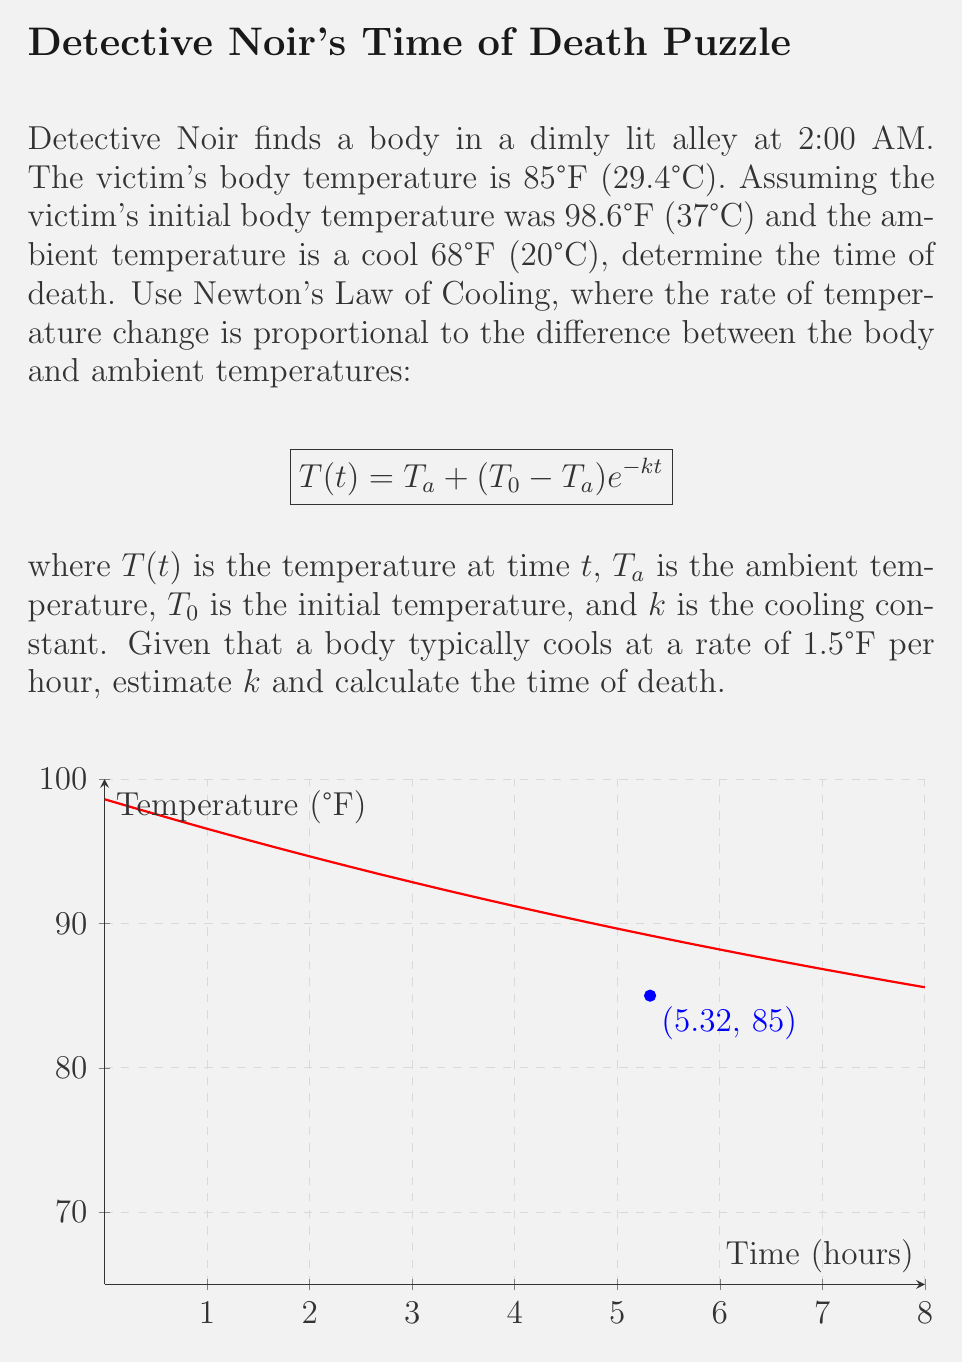Solve this math problem. Let's approach this step-by-step:

1) First, we need to estimate the cooling constant $k$. We're given that a body typically cools at 1.5°F per hour. We can use this to estimate $k$:

   $$\frac{dT}{dt} = -k(T - T_a)$$
   
   At $t=0$, $T=98.6°F$, $T_a=68°F$
   
   $$-1.5 = -k(98.6 - 68)$$
   $$-1.5 = -30.6k$$
   $$k \approx 0.0693$$

2) Now we can use Newton's Law of Cooling:

   $$T(t) = T_a + (T_0 - T_a)e^{-kt}$$

3) Plugging in our values:

   $$85 = 68 + (98.6 - 68)e^{-0.0693t}$$

4) Simplify:

   $$85 = 68 + 30.6e^{-0.0693t}$$
   $$17 = 30.6e^{-0.0693t}$$

5) Take natural log of both sides:

   $$\ln(\frac{17}{30.6}) = -0.0693t$$

6) Solve for $t$:

   $$t = -\frac{\ln(\frac{17}{30.6})}{0.0693} \approx 5.32$$

Therefore, the time of death was approximately 5.32 hours before the body was found.
Answer: 5.32 hours before discovery 